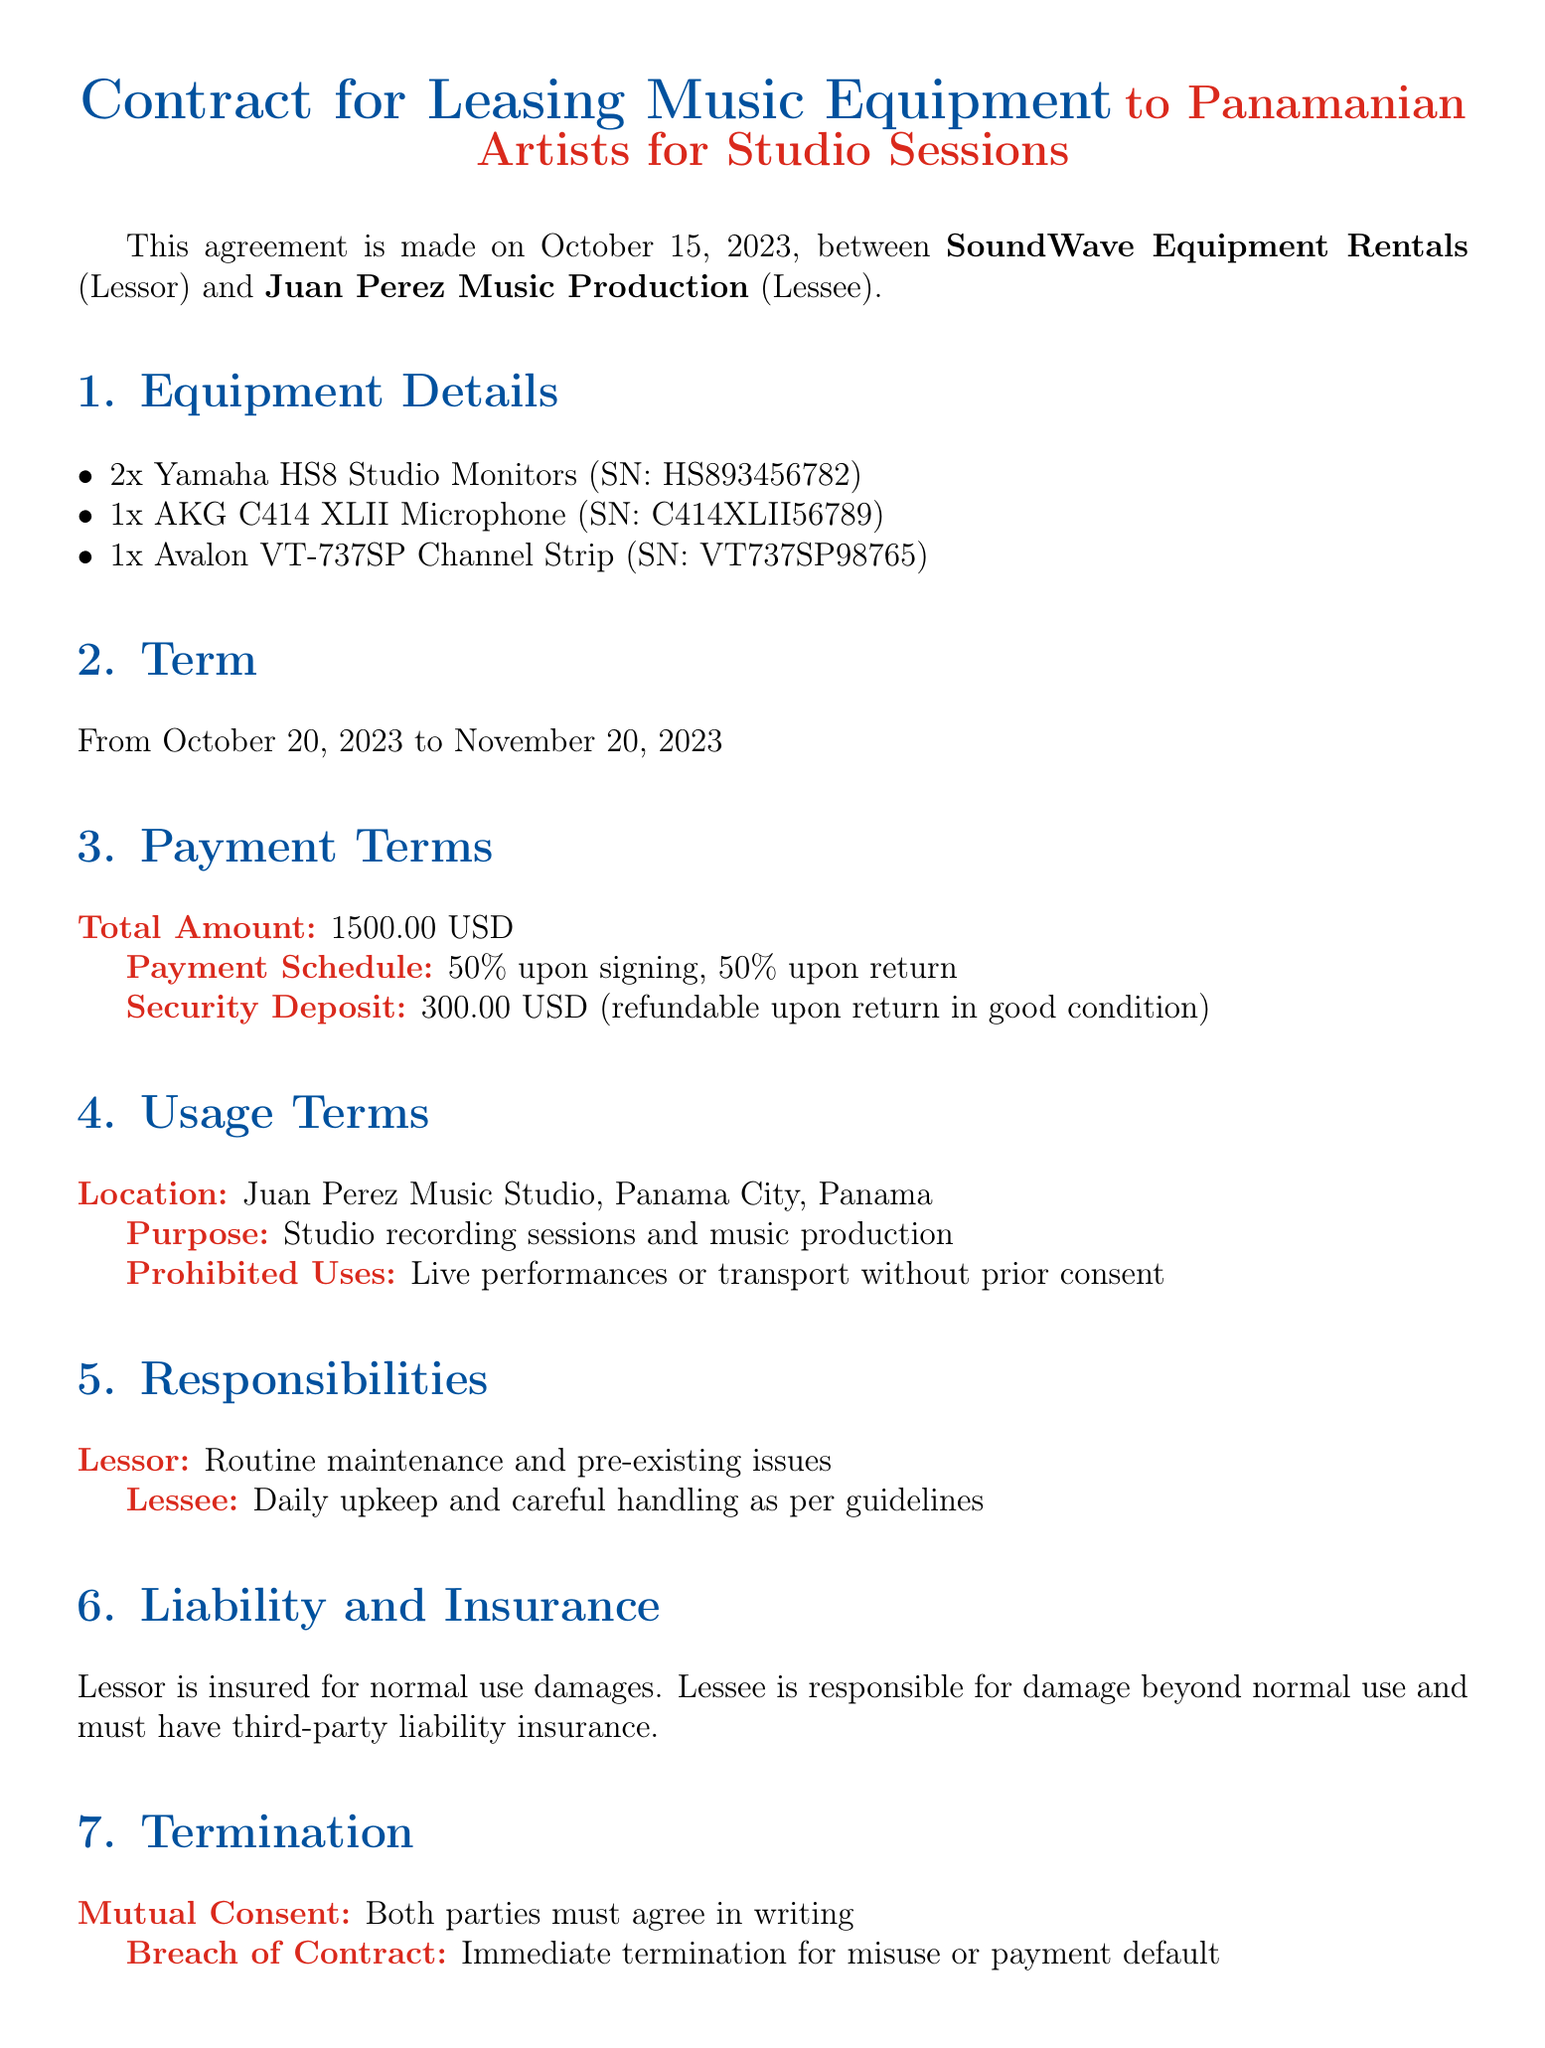What is the total amount for leasing? The total amount for leasing the music equipment, as specified in the Payment Terms section, is stated as 1500.00 USD.
Answer: 1500.00 USD What is the security deposit amount? The security deposit amount, noted in the Payment Terms section, is outlined as being 300.00 USD.
Answer: 300.00 USD What are the studio monitors included in the lease? The Equipment Details section lists the Yamaha HS8 Studio Monitors as part of the leased equipment, specifically mentioning 2 units.
Answer: 2x Yamaha HS8 Studio Monitors What is the start date of the leasing period? The Term section specifies that the leasing period begins on October 20, 2023.
Answer: October 20, 2023 What are the prohibited uses of the equipment? The Usage Terms section identifies that prohibited uses include live performances or transport without prior consent, which is a critical point in responsible equipment use.
Answer: Live performances or transport without prior consent Who is responsible for damage beyond normal use? The liability section states that the Lessee is responsible for damage beyond normal use, indicating a clear understanding of responsibilities for both parties.
Answer: Lessee What is required for termination due to breach of contract? The Termination section mentions that a breach of contract results in immediate termination for misuse or payment default, emphasizing the seriousness of contract adherence.
Answer: Immediate termination Which law governs this contract? The Governing Law section indicates that the contract is governed by the laws of the Republic of Panama.
Answer: Republic of Panama 